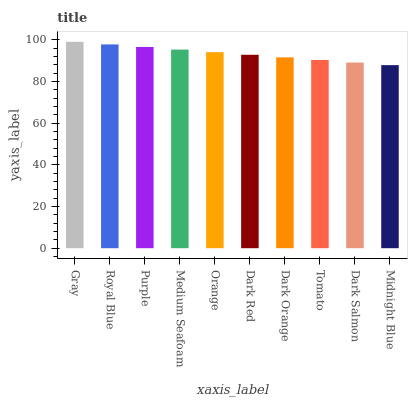Is Royal Blue the minimum?
Answer yes or no. No. Is Royal Blue the maximum?
Answer yes or no. No. Is Gray greater than Royal Blue?
Answer yes or no. Yes. Is Royal Blue less than Gray?
Answer yes or no. Yes. Is Royal Blue greater than Gray?
Answer yes or no. No. Is Gray less than Royal Blue?
Answer yes or no. No. Is Orange the high median?
Answer yes or no. Yes. Is Dark Red the low median?
Answer yes or no. Yes. Is Royal Blue the high median?
Answer yes or no. No. Is Purple the low median?
Answer yes or no. No. 